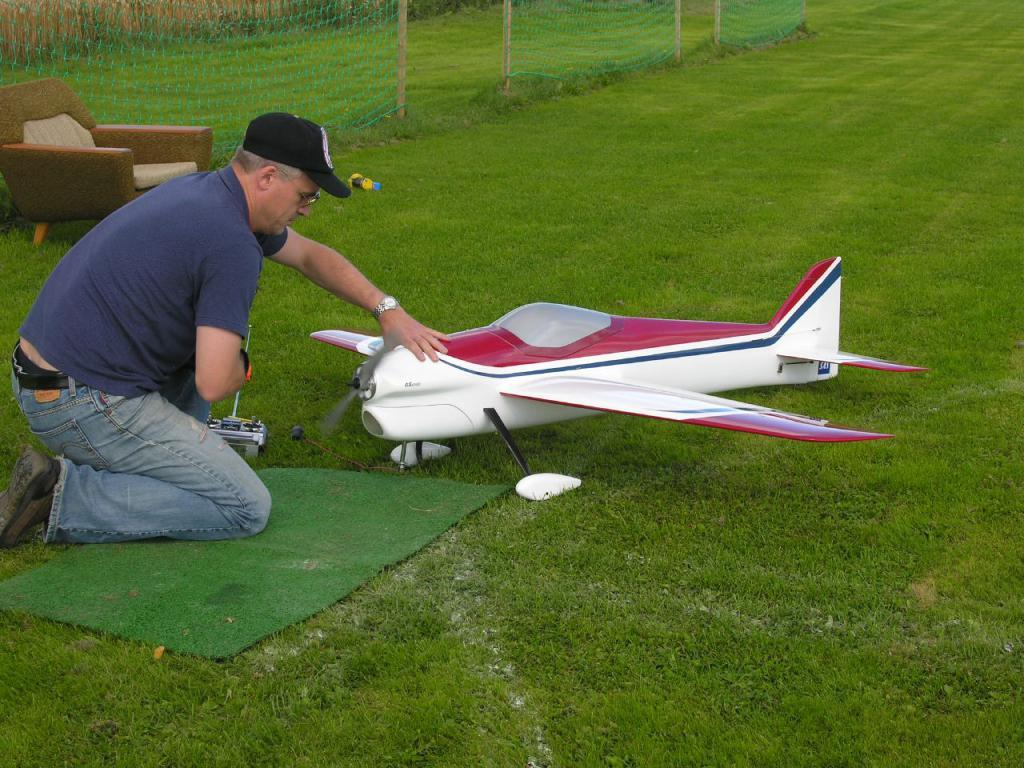What object can be used to control electronic devices in the image? There is a remote controller in the image. What mode of transportation is present in the image? There is an airplane in the image. Where is the airplane located? The airplane is on the grass in the image. Can you describe the person in the image? The person is sitting on their knees. What type of barrier is visible in the image? There is a wire fence in the image. What piece of furniture is present in the image? There is a chair in the image. What type of weather condition is causing the person to rub their hands together in the image? There is no indication of any weather condition in the image, nor is there any person rubbing their hands together. 